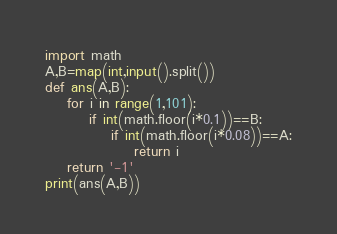<code> <loc_0><loc_0><loc_500><loc_500><_Python_>import math
A,B=map(int,input().split())
def ans(A,B):
	for i in range(1,101):
		if int(math.floor(i*0.1))==B:
			if int(math.floor(i*0.08))==A:
				return i
	return '-1'
print(ans(A,B))</code> 